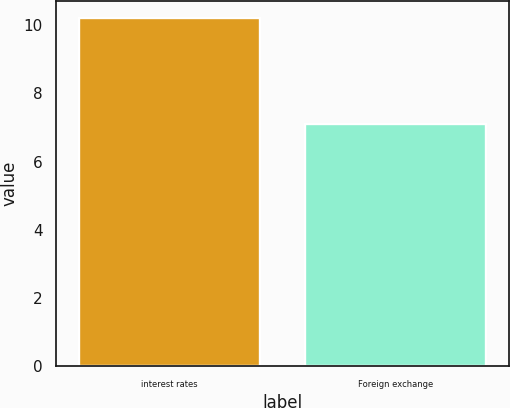Convert chart to OTSL. <chart><loc_0><loc_0><loc_500><loc_500><bar_chart><fcel>interest rates<fcel>Foreign exchange<nl><fcel>10.2<fcel>7.1<nl></chart> 